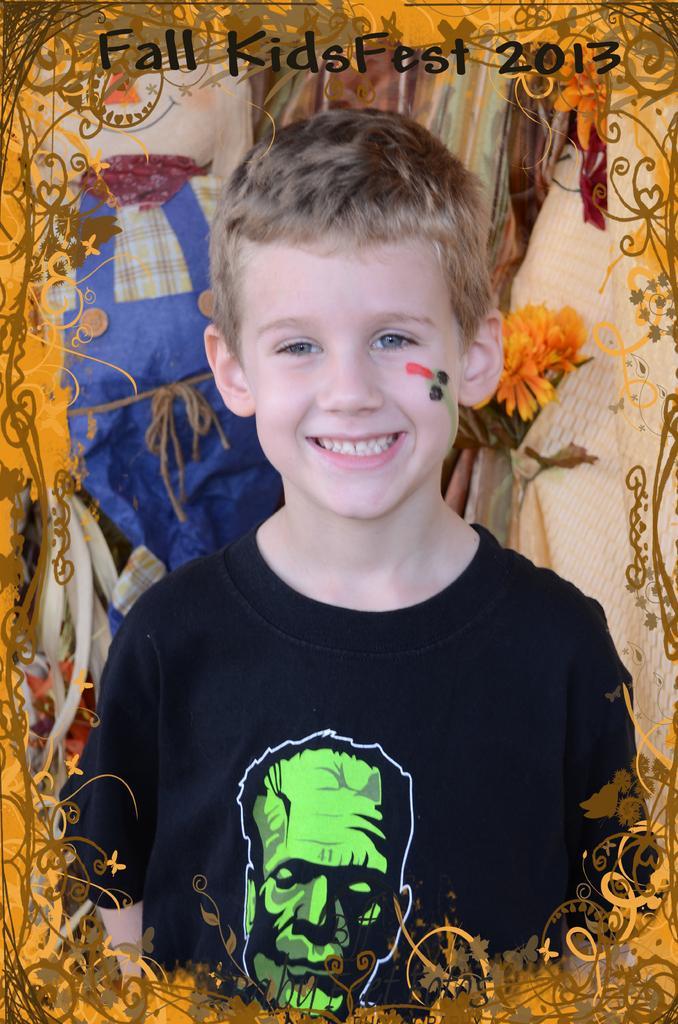Can you describe this image briefly? Here this is an edited image, in which we can see a child standing over a place and we can see he is smiling and we can see flowers present behind him and we can see some other things present. 